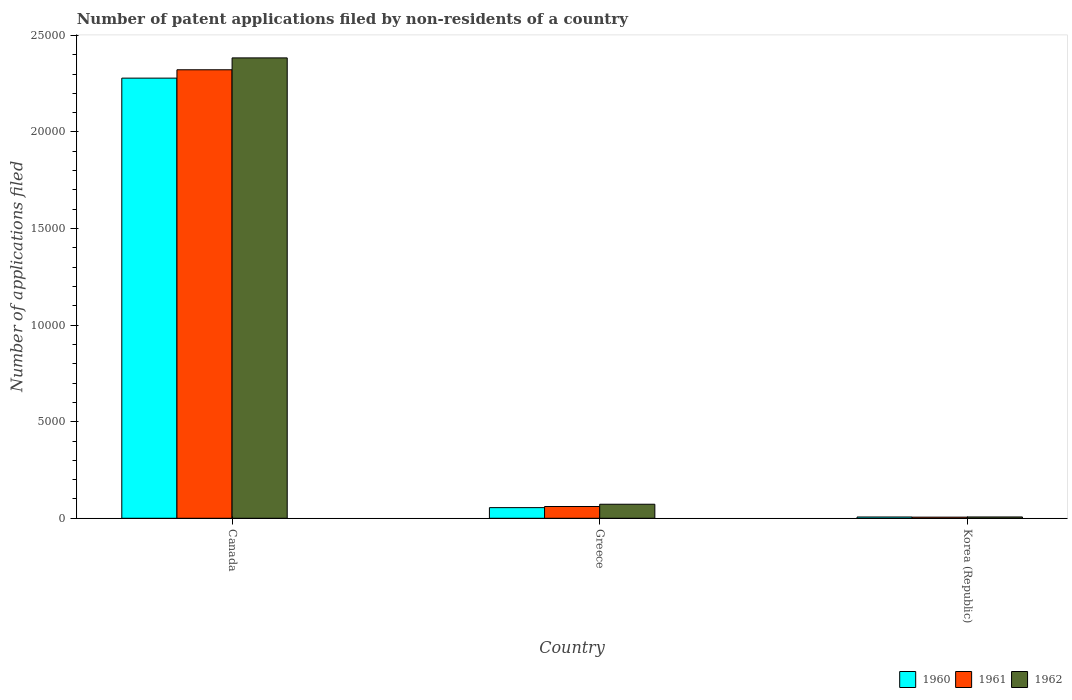How many different coloured bars are there?
Offer a terse response. 3. How many groups of bars are there?
Your answer should be very brief. 3. Are the number of bars on each tick of the X-axis equal?
Give a very brief answer. Yes. How many bars are there on the 3rd tick from the right?
Provide a succinct answer. 3. In how many cases, is the number of bars for a given country not equal to the number of legend labels?
Offer a very short reply. 0. What is the number of applications filed in 1961 in Korea (Republic)?
Your answer should be very brief. 58. Across all countries, what is the maximum number of applications filed in 1962?
Provide a short and direct response. 2.38e+04. Across all countries, what is the minimum number of applications filed in 1961?
Your response must be concise. 58. In which country was the number of applications filed in 1961 maximum?
Your answer should be compact. Canada. What is the total number of applications filed in 1962 in the graph?
Keep it short and to the point. 2.46e+04. What is the difference between the number of applications filed in 1961 in Canada and that in Greece?
Provide a short and direct response. 2.26e+04. What is the difference between the number of applications filed in 1962 in Korea (Republic) and the number of applications filed in 1961 in Canada?
Ensure brevity in your answer.  -2.32e+04. What is the average number of applications filed in 1961 per country?
Keep it short and to the point. 7962. What is the difference between the number of applications filed of/in 1960 and number of applications filed of/in 1962 in Greece?
Give a very brief answer. -175. In how many countries, is the number of applications filed in 1960 greater than 10000?
Provide a succinct answer. 1. What is the ratio of the number of applications filed in 1961 in Greece to that in Korea (Republic)?
Keep it short and to the point. 10.5. Is the difference between the number of applications filed in 1960 in Canada and Greece greater than the difference between the number of applications filed in 1962 in Canada and Greece?
Provide a succinct answer. No. What is the difference between the highest and the second highest number of applications filed in 1960?
Keep it short and to the point. 2.27e+04. What is the difference between the highest and the lowest number of applications filed in 1962?
Offer a terse response. 2.38e+04. Is the sum of the number of applications filed in 1960 in Canada and Greece greater than the maximum number of applications filed in 1962 across all countries?
Your response must be concise. No. Is it the case that in every country, the sum of the number of applications filed in 1962 and number of applications filed in 1961 is greater than the number of applications filed in 1960?
Your answer should be very brief. Yes. How many bars are there?
Offer a very short reply. 9. How many countries are there in the graph?
Provide a succinct answer. 3. What is the difference between two consecutive major ticks on the Y-axis?
Provide a short and direct response. 5000. How many legend labels are there?
Provide a succinct answer. 3. What is the title of the graph?
Your answer should be very brief. Number of patent applications filed by non-residents of a country. Does "1987" appear as one of the legend labels in the graph?
Give a very brief answer. No. What is the label or title of the X-axis?
Offer a very short reply. Country. What is the label or title of the Y-axis?
Offer a terse response. Number of applications filed. What is the Number of applications filed in 1960 in Canada?
Your response must be concise. 2.28e+04. What is the Number of applications filed of 1961 in Canada?
Keep it short and to the point. 2.32e+04. What is the Number of applications filed in 1962 in Canada?
Provide a short and direct response. 2.38e+04. What is the Number of applications filed in 1960 in Greece?
Provide a succinct answer. 551. What is the Number of applications filed in 1961 in Greece?
Your answer should be very brief. 609. What is the Number of applications filed in 1962 in Greece?
Provide a short and direct response. 726. What is the Number of applications filed in 1960 in Korea (Republic)?
Give a very brief answer. 66. What is the Number of applications filed of 1961 in Korea (Republic)?
Keep it short and to the point. 58. What is the Number of applications filed in 1962 in Korea (Republic)?
Provide a succinct answer. 68. Across all countries, what is the maximum Number of applications filed of 1960?
Provide a succinct answer. 2.28e+04. Across all countries, what is the maximum Number of applications filed of 1961?
Give a very brief answer. 2.32e+04. Across all countries, what is the maximum Number of applications filed in 1962?
Your answer should be compact. 2.38e+04. Across all countries, what is the minimum Number of applications filed of 1960?
Provide a short and direct response. 66. What is the total Number of applications filed in 1960 in the graph?
Keep it short and to the point. 2.34e+04. What is the total Number of applications filed of 1961 in the graph?
Offer a terse response. 2.39e+04. What is the total Number of applications filed in 1962 in the graph?
Ensure brevity in your answer.  2.46e+04. What is the difference between the Number of applications filed of 1960 in Canada and that in Greece?
Make the answer very short. 2.22e+04. What is the difference between the Number of applications filed of 1961 in Canada and that in Greece?
Provide a succinct answer. 2.26e+04. What is the difference between the Number of applications filed in 1962 in Canada and that in Greece?
Ensure brevity in your answer.  2.31e+04. What is the difference between the Number of applications filed of 1960 in Canada and that in Korea (Republic)?
Your response must be concise. 2.27e+04. What is the difference between the Number of applications filed of 1961 in Canada and that in Korea (Republic)?
Your answer should be compact. 2.32e+04. What is the difference between the Number of applications filed in 1962 in Canada and that in Korea (Republic)?
Offer a terse response. 2.38e+04. What is the difference between the Number of applications filed of 1960 in Greece and that in Korea (Republic)?
Ensure brevity in your answer.  485. What is the difference between the Number of applications filed in 1961 in Greece and that in Korea (Republic)?
Provide a short and direct response. 551. What is the difference between the Number of applications filed of 1962 in Greece and that in Korea (Republic)?
Offer a terse response. 658. What is the difference between the Number of applications filed of 1960 in Canada and the Number of applications filed of 1961 in Greece?
Offer a very short reply. 2.22e+04. What is the difference between the Number of applications filed of 1960 in Canada and the Number of applications filed of 1962 in Greece?
Provide a short and direct response. 2.21e+04. What is the difference between the Number of applications filed of 1961 in Canada and the Number of applications filed of 1962 in Greece?
Your answer should be compact. 2.25e+04. What is the difference between the Number of applications filed of 1960 in Canada and the Number of applications filed of 1961 in Korea (Republic)?
Give a very brief answer. 2.27e+04. What is the difference between the Number of applications filed of 1960 in Canada and the Number of applications filed of 1962 in Korea (Republic)?
Your answer should be compact. 2.27e+04. What is the difference between the Number of applications filed of 1961 in Canada and the Number of applications filed of 1962 in Korea (Republic)?
Your answer should be compact. 2.32e+04. What is the difference between the Number of applications filed of 1960 in Greece and the Number of applications filed of 1961 in Korea (Republic)?
Give a very brief answer. 493. What is the difference between the Number of applications filed in 1960 in Greece and the Number of applications filed in 1962 in Korea (Republic)?
Provide a succinct answer. 483. What is the difference between the Number of applications filed of 1961 in Greece and the Number of applications filed of 1962 in Korea (Republic)?
Make the answer very short. 541. What is the average Number of applications filed in 1960 per country?
Offer a very short reply. 7801. What is the average Number of applications filed of 1961 per country?
Offer a terse response. 7962. What is the average Number of applications filed of 1962 per country?
Your answer should be compact. 8209.33. What is the difference between the Number of applications filed in 1960 and Number of applications filed in 1961 in Canada?
Offer a terse response. -433. What is the difference between the Number of applications filed in 1960 and Number of applications filed in 1962 in Canada?
Your answer should be compact. -1048. What is the difference between the Number of applications filed of 1961 and Number of applications filed of 1962 in Canada?
Provide a short and direct response. -615. What is the difference between the Number of applications filed of 1960 and Number of applications filed of 1961 in Greece?
Keep it short and to the point. -58. What is the difference between the Number of applications filed in 1960 and Number of applications filed in 1962 in Greece?
Offer a very short reply. -175. What is the difference between the Number of applications filed in 1961 and Number of applications filed in 1962 in Greece?
Your response must be concise. -117. What is the difference between the Number of applications filed of 1961 and Number of applications filed of 1962 in Korea (Republic)?
Make the answer very short. -10. What is the ratio of the Number of applications filed in 1960 in Canada to that in Greece?
Keep it short and to the point. 41.35. What is the ratio of the Number of applications filed of 1961 in Canada to that in Greece?
Provide a short and direct response. 38.13. What is the ratio of the Number of applications filed of 1962 in Canada to that in Greece?
Offer a very short reply. 32.83. What is the ratio of the Number of applications filed in 1960 in Canada to that in Korea (Republic)?
Provide a succinct answer. 345.24. What is the ratio of the Number of applications filed in 1961 in Canada to that in Korea (Republic)?
Your answer should be very brief. 400.33. What is the ratio of the Number of applications filed of 1962 in Canada to that in Korea (Republic)?
Offer a terse response. 350.5. What is the ratio of the Number of applications filed in 1960 in Greece to that in Korea (Republic)?
Ensure brevity in your answer.  8.35. What is the ratio of the Number of applications filed of 1961 in Greece to that in Korea (Republic)?
Give a very brief answer. 10.5. What is the ratio of the Number of applications filed in 1962 in Greece to that in Korea (Republic)?
Offer a terse response. 10.68. What is the difference between the highest and the second highest Number of applications filed of 1960?
Offer a very short reply. 2.22e+04. What is the difference between the highest and the second highest Number of applications filed in 1961?
Give a very brief answer. 2.26e+04. What is the difference between the highest and the second highest Number of applications filed of 1962?
Make the answer very short. 2.31e+04. What is the difference between the highest and the lowest Number of applications filed of 1960?
Your answer should be compact. 2.27e+04. What is the difference between the highest and the lowest Number of applications filed of 1961?
Ensure brevity in your answer.  2.32e+04. What is the difference between the highest and the lowest Number of applications filed in 1962?
Ensure brevity in your answer.  2.38e+04. 